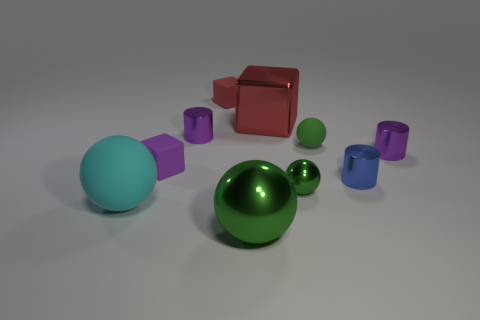Does this image suggest any particular theme or concept? Certainly, the image might be interpreted as a representation of diversity and harmony. The different shapes and colors coexist peacefully, possibly hinting at the idea that variety in a system - such as a community or ecosystem - can contribute to its vibrance and functionality. Can you elaborate on how these shapes might interact in a real-world scenario? In a real-world setting, these shapes could symbolize various elements interacting in a space. For instance, the spheres could represent dynamic components that roll and cause motion, while the cubes might suggest stability and structure. The cylinders could serve as connectors or pillars that support and create flow between the different entities. Such an arrangement can be seen in social or ecological systems, where different elements have distinct roles yet work together cohesively. 